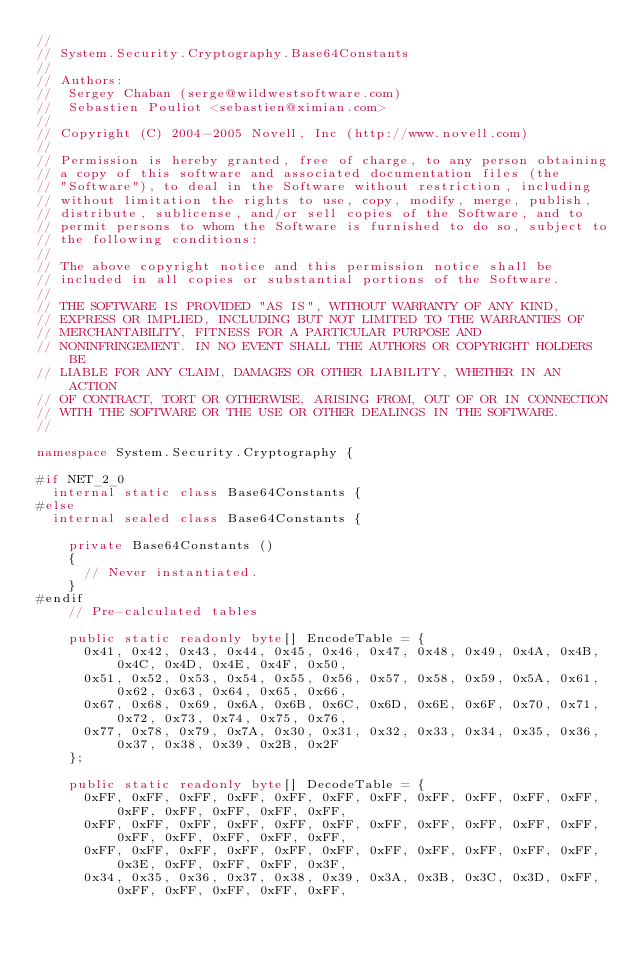Convert code to text. <code><loc_0><loc_0><loc_500><loc_500><_C#_>//
// System.Security.Cryptography.Base64Constants
//
// Authors:
//	Sergey Chaban (serge@wildwestsoftware.com)
//	Sebastien Pouliot <sebastien@ximian.com>
//
// Copyright (C) 2004-2005 Novell, Inc (http://www.novell.com)
//
// Permission is hereby granted, free of charge, to any person obtaining
// a copy of this software and associated documentation files (the
// "Software"), to deal in the Software without restriction, including
// without limitation the rights to use, copy, modify, merge, publish,
// distribute, sublicense, and/or sell copies of the Software, and to
// permit persons to whom the Software is furnished to do so, subject to
// the following conditions:
// 
// The above copyright notice and this permission notice shall be
// included in all copies or substantial portions of the Software.
// 
// THE SOFTWARE IS PROVIDED "AS IS", WITHOUT WARRANTY OF ANY KIND,
// EXPRESS OR IMPLIED, INCLUDING BUT NOT LIMITED TO THE WARRANTIES OF
// MERCHANTABILITY, FITNESS FOR A PARTICULAR PURPOSE AND
// NONINFRINGEMENT. IN NO EVENT SHALL THE AUTHORS OR COPYRIGHT HOLDERS BE
// LIABLE FOR ANY CLAIM, DAMAGES OR OTHER LIABILITY, WHETHER IN AN ACTION
// OF CONTRACT, TORT OR OTHERWISE, ARISING FROM, OUT OF OR IN CONNECTION
// WITH THE SOFTWARE OR THE USE OR OTHER DEALINGS IN THE SOFTWARE.
//

namespace System.Security.Cryptography {

#if NET_2_0
	internal static class Base64Constants {
#else
	internal sealed class Base64Constants {

		private Base64Constants ()
		{
			// Never instantiated.
		}
#endif
		// Pre-calculated tables

		public static readonly byte[] EncodeTable = { 
			0x41, 0x42, 0x43, 0x44, 0x45, 0x46, 0x47, 0x48, 0x49, 0x4A, 0x4B, 0x4C, 0x4D, 0x4E, 0x4F, 0x50, 
			0x51, 0x52, 0x53, 0x54, 0x55, 0x56, 0x57, 0x58, 0x59, 0x5A, 0x61, 0x62, 0x63, 0x64, 0x65, 0x66, 
			0x67, 0x68, 0x69, 0x6A, 0x6B, 0x6C, 0x6D, 0x6E, 0x6F, 0x70, 0x71, 0x72, 0x73, 0x74, 0x75, 0x76, 
			0x77, 0x78, 0x79, 0x7A, 0x30, 0x31, 0x32, 0x33, 0x34, 0x35, 0x36, 0x37, 0x38, 0x39, 0x2B, 0x2F 
		};

		public static readonly byte[] DecodeTable = {
			0xFF, 0xFF, 0xFF, 0xFF, 0xFF, 0xFF, 0xFF, 0xFF, 0xFF, 0xFF, 0xFF, 0xFF, 0xFF, 0xFF, 0xFF, 0xFF, 
			0xFF, 0xFF, 0xFF, 0xFF, 0xFF, 0xFF, 0xFF, 0xFF, 0xFF, 0xFF, 0xFF, 0xFF, 0xFF, 0xFF, 0xFF, 0xFF, 
			0xFF, 0xFF, 0xFF, 0xFF, 0xFF, 0xFF, 0xFF, 0xFF, 0xFF, 0xFF, 0xFF, 0x3E, 0xFF, 0xFF, 0xFF, 0x3F, 
			0x34, 0x35, 0x36, 0x37, 0x38, 0x39, 0x3A, 0x3B, 0x3C, 0x3D, 0xFF, 0xFF, 0xFF, 0xFF, 0xFF, 0xFF, </code> 